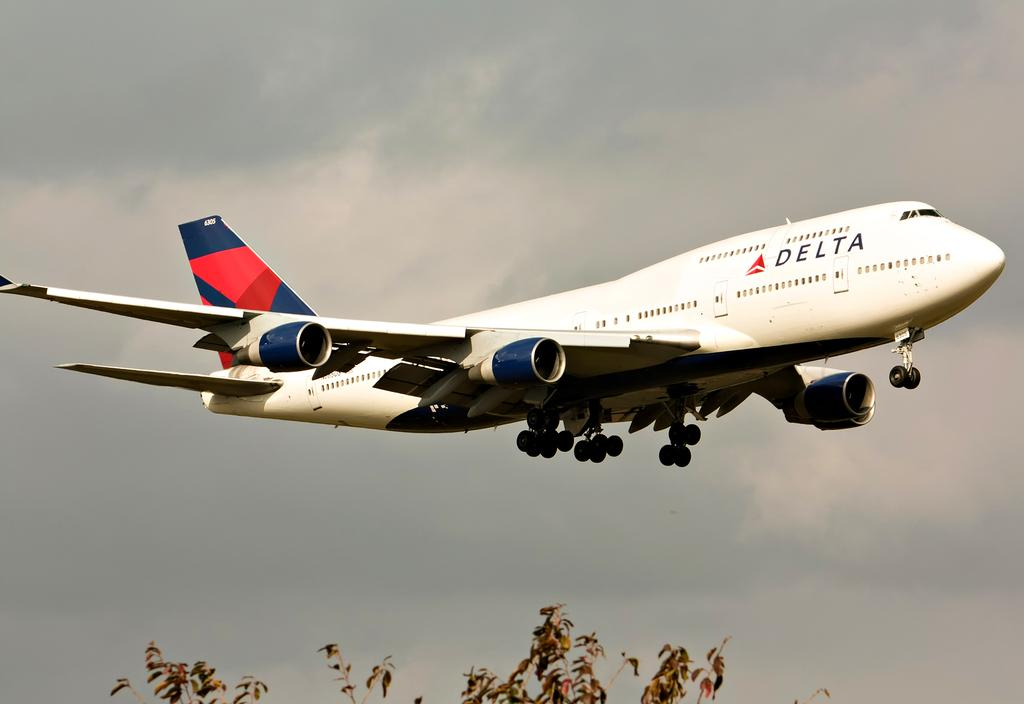<image>
Present a compact description of the photo's key features. The Delta Plane is flying in a partly cloudy sky. 